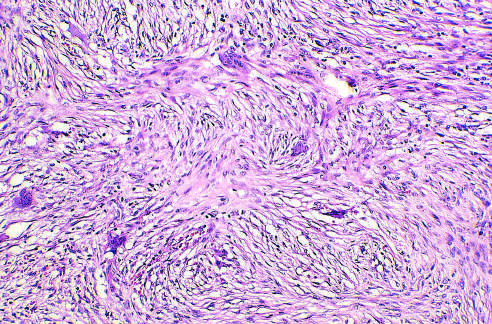what is composed of curvilinear trabeculae of woven bone that lack conspicuous osteoblastic rimming and arise in a background of fibrous tissue?
Answer the question using a single word or phrase. Fibrous dysplasia 